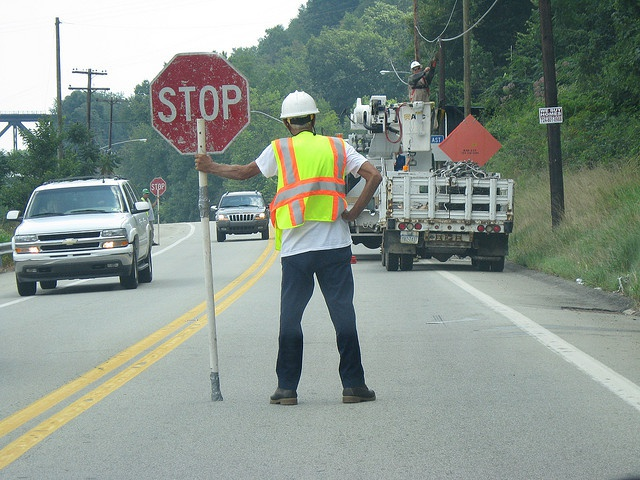Describe the objects in this image and their specific colors. I can see people in white, black, darkblue, gray, and darkgray tones, truck in white, darkgray, gray, black, and lightgray tones, truck in white, gray, black, and darkgray tones, car in white, gray, and darkgray tones, and stop sign in white, brown, and darkgray tones in this image. 